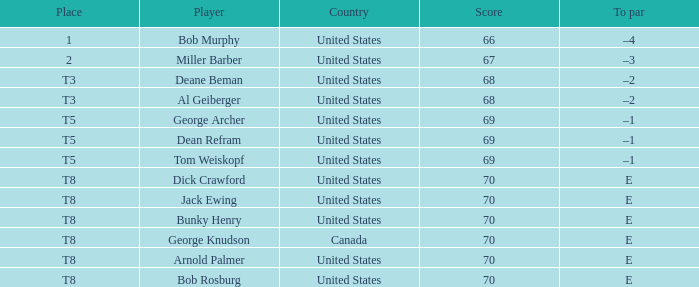In the event that bunky henry from the united states had a score greater than 68 and a to par of e, what was his standing? T8. Can you give me this table as a dict? {'header': ['Place', 'Player', 'Country', 'Score', 'To par'], 'rows': [['1', 'Bob Murphy', 'United States', '66', '–4'], ['2', 'Miller Barber', 'United States', '67', '–3'], ['T3', 'Deane Beman', 'United States', '68', '–2'], ['T3', 'Al Geiberger', 'United States', '68', '–2'], ['T5', 'George Archer', 'United States', '69', '–1'], ['T5', 'Dean Refram', 'United States', '69', '–1'], ['T5', 'Tom Weiskopf', 'United States', '69', '–1'], ['T8', 'Dick Crawford', 'United States', '70', 'E'], ['T8', 'Jack Ewing', 'United States', '70', 'E'], ['T8', 'Bunky Henry', 'United States', '70', 'E'], ['T8', 'George Knudson', 'Canada', '70', 'E'], ['T8', 'Arnold Palmer', 'United States', '70', 'E'], ['T8', 'Bob Rosburg', 'United States', '70', 'E']]} 